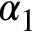<formula> <loc_0><loc_0><loc_500><loc_500>\alpha _ { 1 }</formula> 